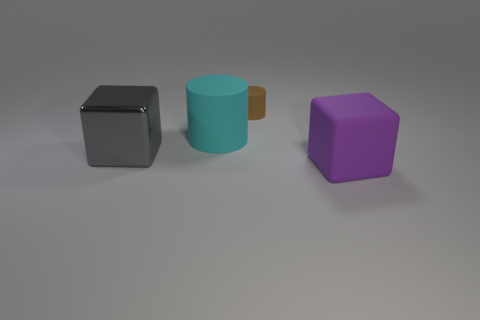Add 1 brown matte cylinders. How many objects exist? 5 Add 3 big rubber cylinders. How many big rubber cylinders are left? 4 Add 1 brown rubber cylinders. How many brown rubber cylinders exist? 2 Subtract 0 yellow balls. How many objects are left? 4 Subtract all large matte blocks. Subtract all gray metallic objects. How many objects are left? 2 